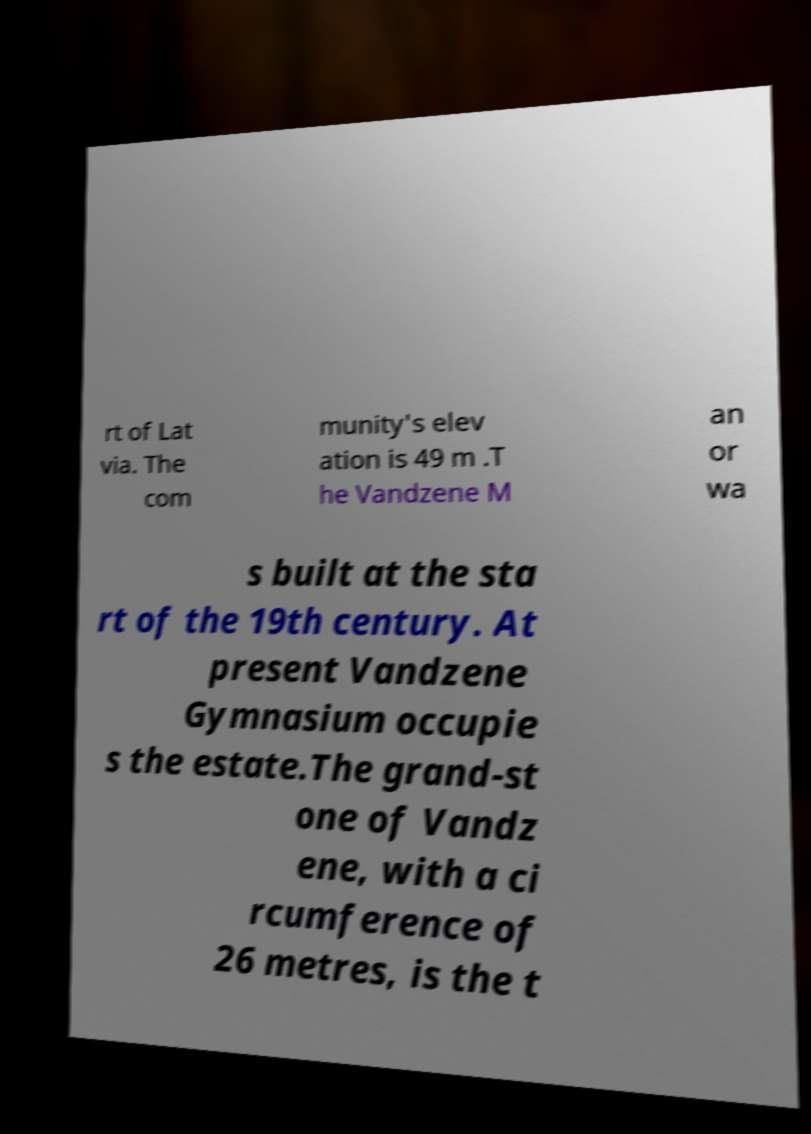Could you assist in decoding the text presented in this image and type it out clearly? rt of Lat via. The com munity's elev ation is 49 m .T he Vandzene M an or wa s built at the sta rt of the 19th century. At present Vandzene Gymnasium occupie s the estate.The grand-st one of Vandz ene, with a ci rcumference of 26 metres, is the t 